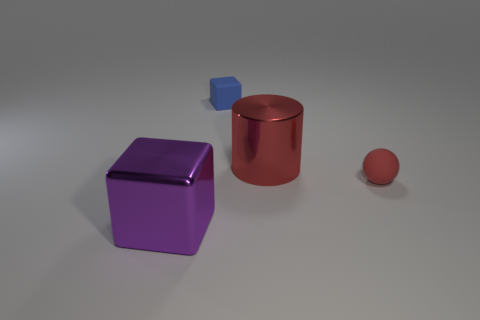Add 4 large brown things. How many objects exist? 8 Subtract all purple cubes. How many cubes are left? 1 Subtract all spheres. How many objects are left? 3 Subtract 1 spheres. How many spheres are left? 0 Subtract all brown cylinders. How many blue blocks are left? 1 Subtract all green metallic cylinders. Subtract all rubber blocks. How many objects are left? 3 Add 3 blue matte blocks. How many blue matte blocks are left? 4 Add 4 purple metallic cubes. How many purple metallic cubes exist? 5 Subtract 0 cyan cylinders. How many objects are left? 4 Subtract all green cylinders. Subtract all red cubes. How many cylinders are left? 1 